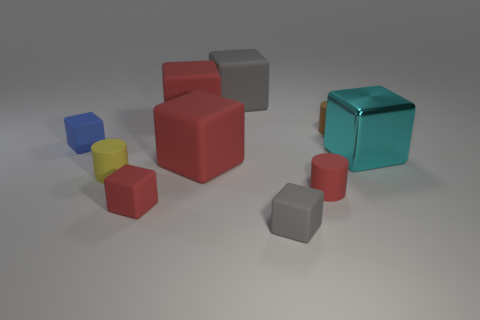Does the brown cylinder have the same material as the yellow object?
Keep it short and to the point. Yes. There is a tiny cube that is behind the big object that is in front of the cyan thing; are there any tiny brown matte cylinders on the right side of it?
Give a very brief answer. Yes. What number of other things are the same shape as the small blue object?
Your answer should be very brief. 6. What shape is the small rubber thing that is behind the yellow thing and to the right of the big gray rubber thing?
Your response must be concise. Cylinder. There is a cube in front of the tiny red object that is left of the gray thing that is in front of the tiny blue block; what is its color?
Ensure brevity in your answer.  Gray. Are there more tiny gray rubber objects on the left side of the big cyan metallic block than blue objects in front of the small blue cube?
Your answer should be very brief. Yes. What number of other things are there of the same size as the cyan metallic thing?
Your answer should be very brief. 3. What is the large object right of the gray object left of the small gray rubber thing made of?
Offer a very short reply. Metal. There is a tiny blue object; are there any tiny yellow cylinders on the right side of it?
Keep it short and to the point. Yes. Is the number of small red objects in front of the large gray matte thing greater than the number of tiny yellow metal balls?
Your response must be concise. Yes. 